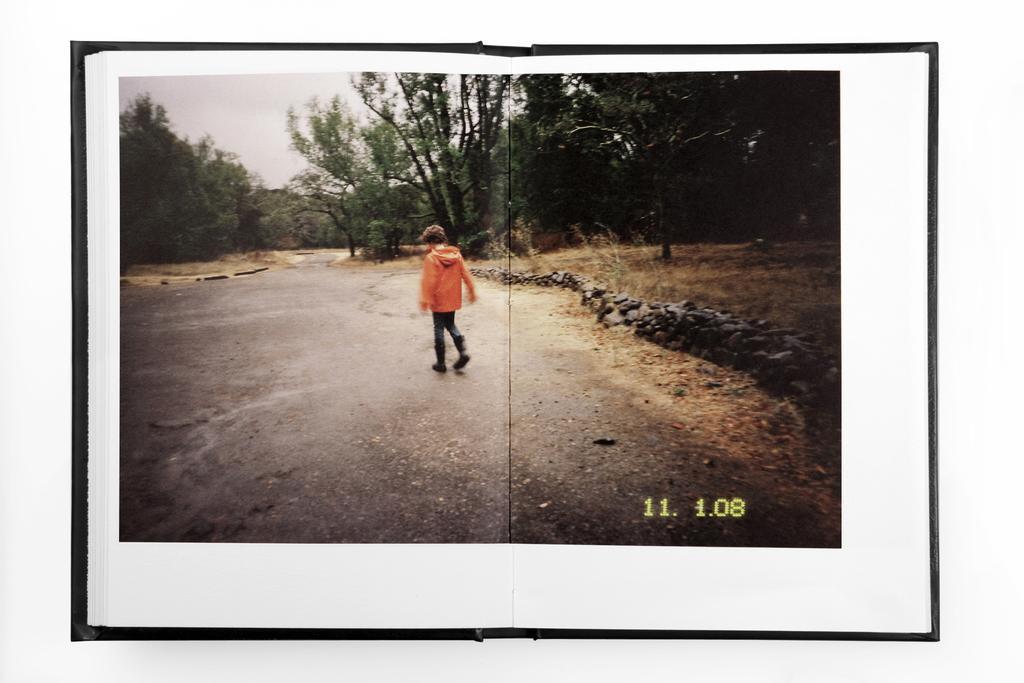Describe this image in one or two sentences. This is an edited image. We can see a person is standing on the road. In front of the person there are trees and the sky. On the image, there is a watermark. 